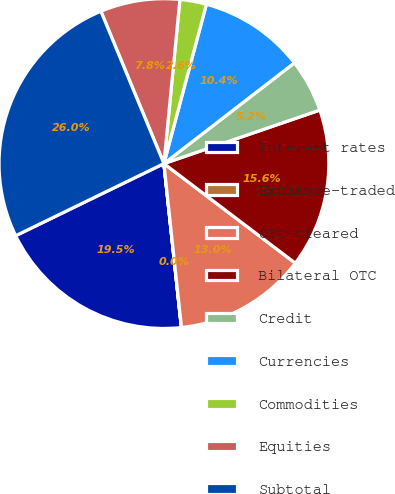<chart> <loc_0><loc_0><loc_500><loc_500><pie_chart><fcel>Interest rates<fcel>Exchange-traded<fcel>OTC-cleared<fcel>Bilateral OTC<fcel>Credit<fcel>Currencies<fcel>Commodities<fcel>Equities<fcel>Subtotal<nl><fcel>19.48%<fcel>0.01%<fcel>12.98%<fcel>15.58%<fcel>5.2%<fcel>10.39%<fcel>2.6%<fcel>7.79%<fcel>25.96%<nl></chart> 